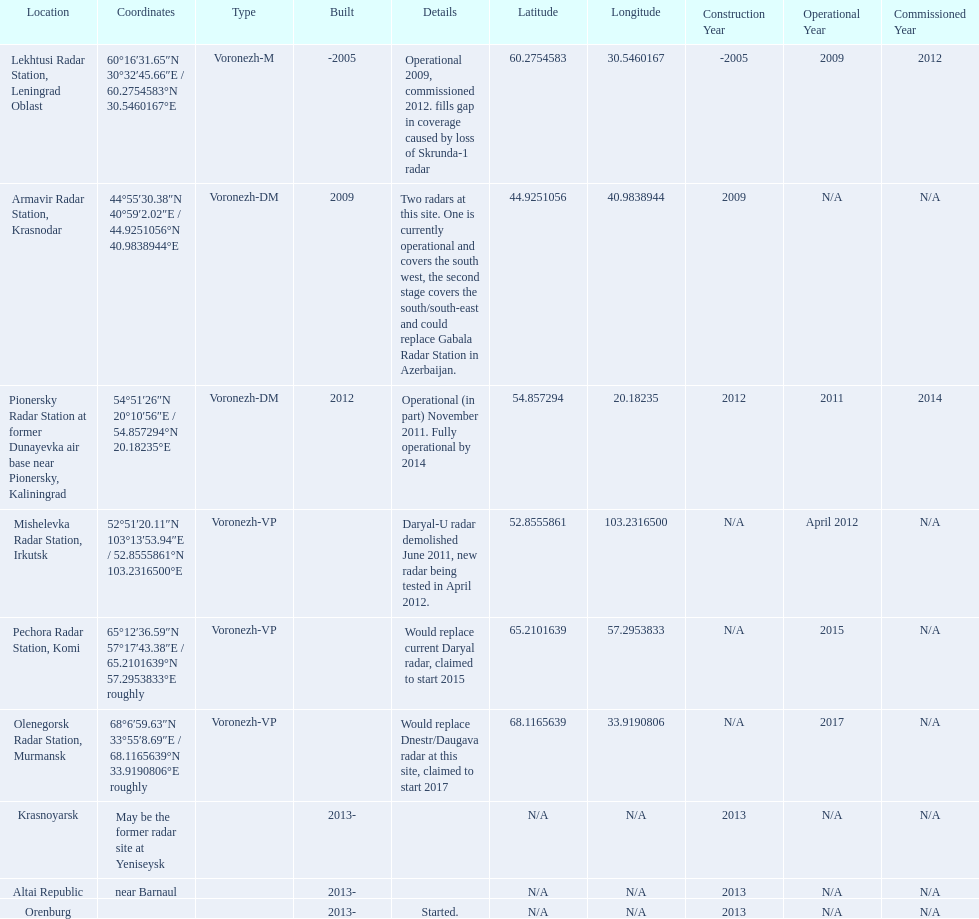What are all of the locations? Lekhtusi Radar Station, Leningrad Oblast, Armavir Radar Station, Krasnodar, Pionersky Radar Station at former Dunayevka air base near Pionersky, Kaliningrad, Mishelevka Radar Station, Irkutsk, Pechora Radar Station, Komi, Olenegorsk Radar Station, Murmansk, Krasnoyarsk, Altai Republic, Orenburg. And which location's coordinates are 60deg16'31.65''n 30deg32'45.66''e / 60.2754583degn 30.5460167dege? Lekhtusi Radar Station, Leningrad Oblast. 